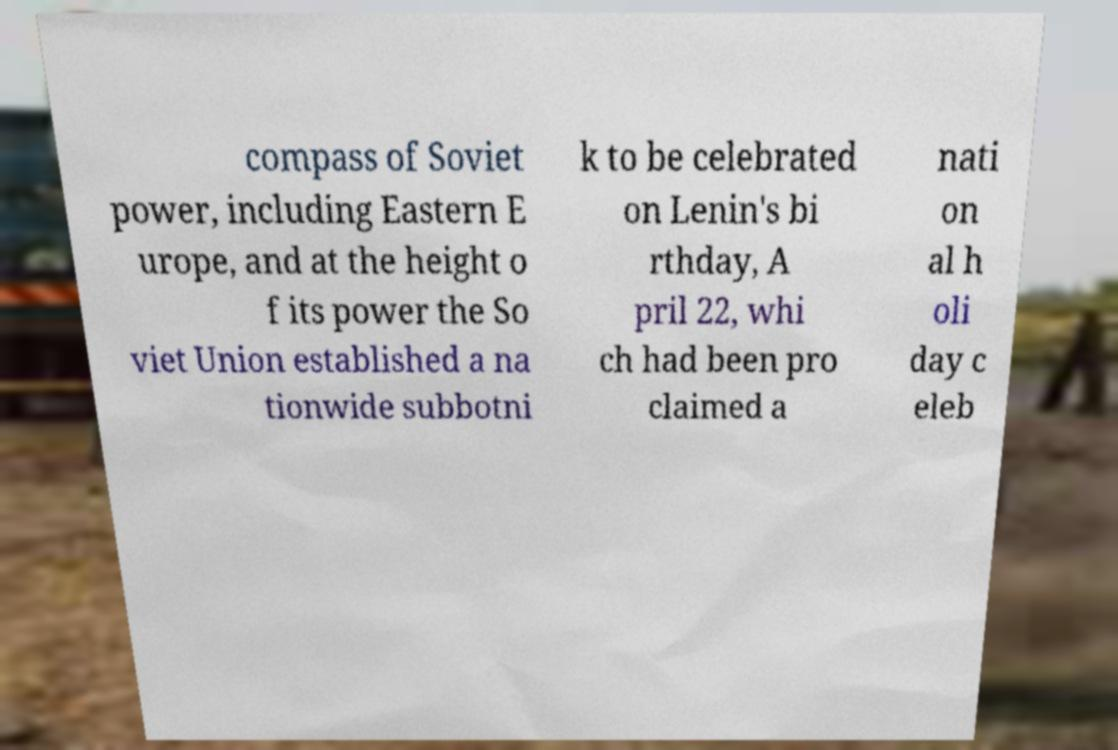Could you assist in decoding the text presented in this image and type it out clearly? compass of Soviet power, including Eastern E urope, and at the height o f its power the So viet Union established a na tionwide subbotni k to be celebrated on Lenin's bi rthday, A pril 22, whi ch had been pro claimed a nati on al h oli day c eleb 